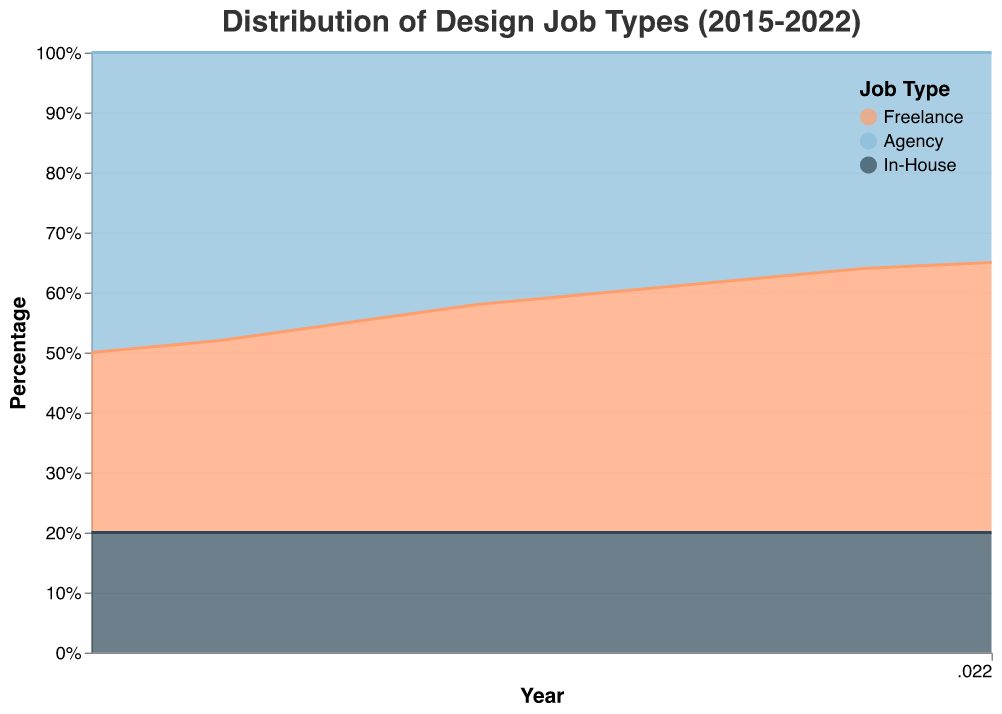What's the title of the chart? The title is typically located at the top of the chart and is used to convey the main subject of the graph. In this case, the title "Distribution of Design Job Types (2015-2022)" indicates that the chart shows how different design job types have varied from 2015 to 2022.
Answer: Distribution of Design Job Types (2015-2022) How many job types are represented in the chart? To determine the number of job types, look at the legend or the different areas of color on the chart. The legend shows three job types: Freelance, Agency, and In-House.
Answer: 3 Which job type shows the most significant increase over the years? Examine the trend and the change in the area sizes for each job type over time. Freelance shows a continuous increase from 2015 to 2022.
Answer: Freelance In which year do Freelance and Agency job types have equal distribution? Look at the intersection points of the areas representing Freelance and Agency. In 2019, the areas of Freelance and Agency are equal.
Answer: 2019 What is the trend for In-House job types over the years? To identify the trend, observe the area corresponding to In-House job types from 2015 to 2022. The area for In-House job types remains constant over the years.
Answer: Constant What's the percentage of Freelance jobs in 2020? Since this is a 100% stacked area chart, look at the height of the Freelance area at the year 2020. Freelance takes up 42% of the total area in 2020.
Answer: 42% How does the percentage of Agency jobs change from 2015 to 2022? To determine the change, compare the height of the Agency area from 2015 to 2022. The percentage of Agency jobs decreases from 50% in 2015 to 35% in 2022.
Answer: Decreases from 50% to 35% Which job type remained constant while others changed? Identify the job type by looking at the areas representing each job type. In-House remains at a constant 20% throughout the years.
Answer: In-House In which year is there the smallest percentage difference between Freelance and Agency jobs? Calculate the percentage difference by comparing the areas for Freelance and Agency jobs for each year. The smallest percentage difference occurs in 2019 when both are 40%.
Answer: 2019 What can you infer about the overall trend of Freelance and Agency jobs from 2015 to 2022? Analyzing the trends, Freelance jobs are increasing while Agency jobs are decreasing over this period.
Answer: Freelance increasing, Agency decreasing 